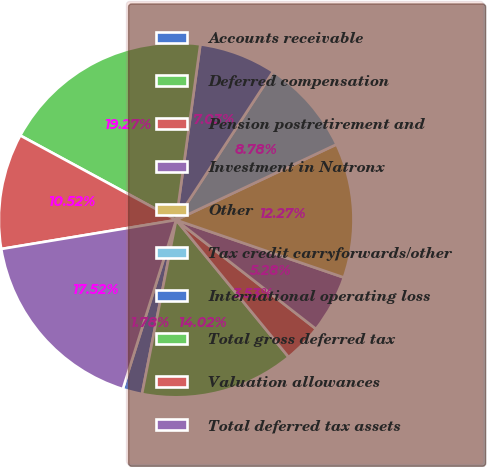Convert chart. <chart><loc_0><loc_0><loc_500><loc_500><pie_chart><fcel>Accounts receivable<fcel>Deferred compensation<fcel>Pension postretirement and<fcel>Investment in Natronx<fcel>Other<fcel>Tax credit carryforwards/other<fcel>International operating loss<fcel>Total gross deferred tax<fcel>Valuation allowances<fcel>Total deferred tax assets<nl><fcel>1.78%<fcel>14.02%<fcel>3.53%<fcel>5.28%<fcel>12.27%<fcel>8.78%<fcel>7.03%<fcel>19.27%<fcel>10.52%<fcel>17.52%<nl></chart> 